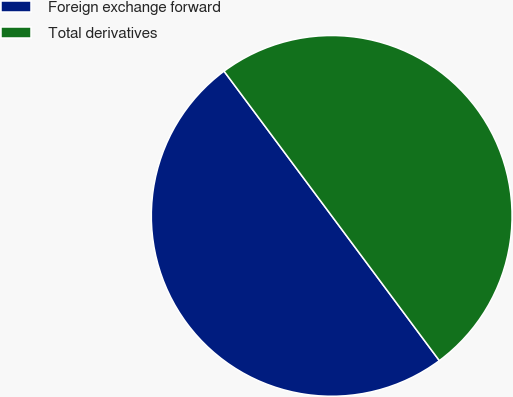Convert chart. <chart><loc_0><loc_0><loc_500><loc_500><pie_chart><fcel>Foreign exchange forward<fcel>Total derivatives<nl><fcel>50.0%<fcel>50.0%<nl></chart> 